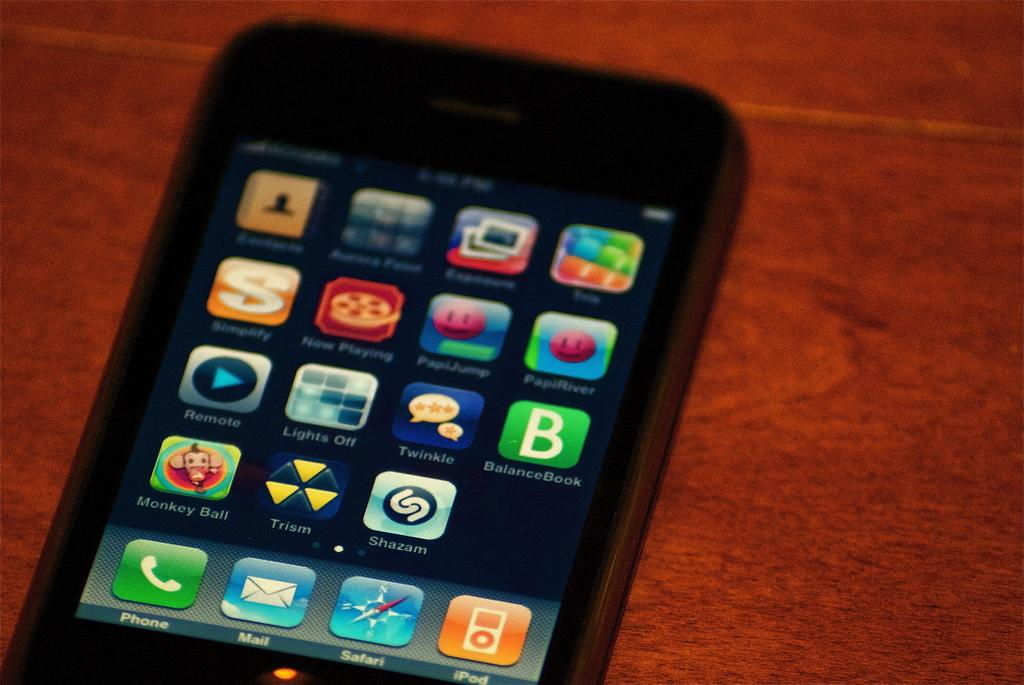Provide a one-sentence caption for the provided image. A smart phone has a number of apps installed including Monkey Ball. 